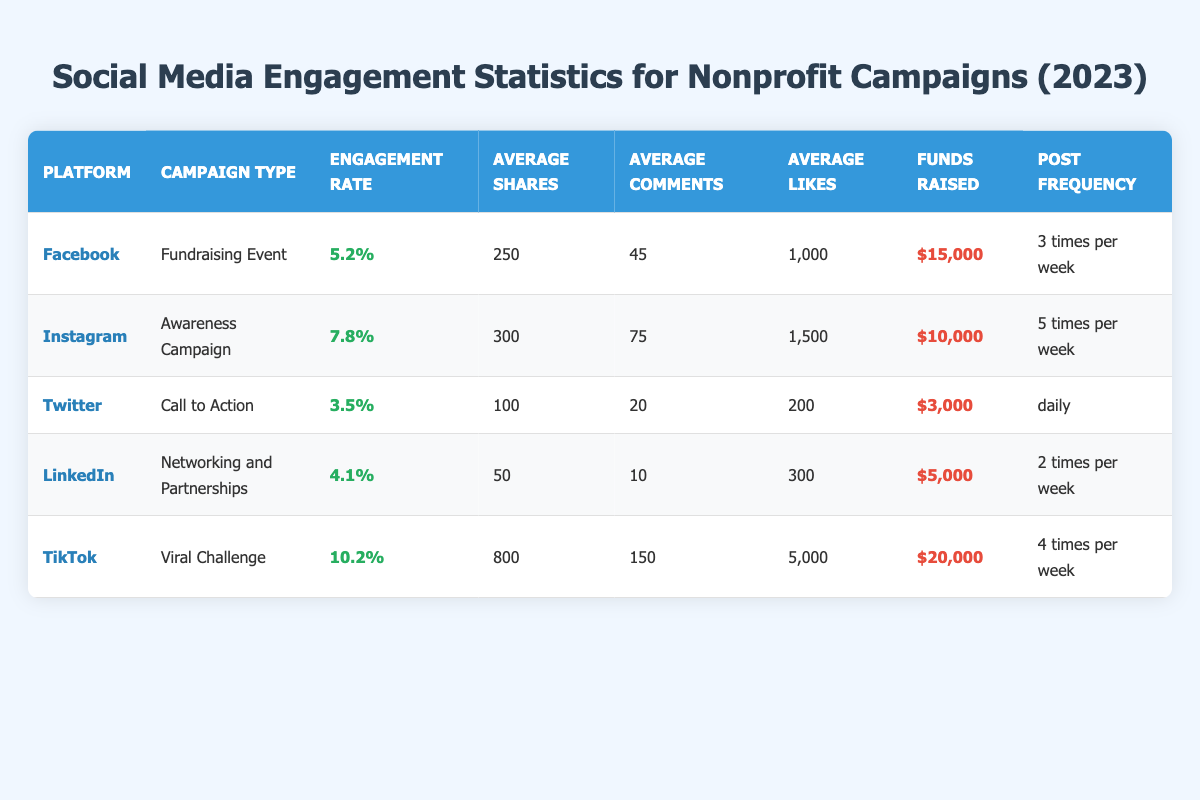What is the engagement rate for TikTok campaigns? The table shows that the engagement rate for TikTok campaigns is listed under the "Engagement Rate" column for TikTok, which is 10.2%.
Answer: 10.2% How many average likes did the Awareness Campaign on Instagram receive? Referring to the table, the average likes for the Awareness Campaign on Instagram are specifically noted as 1500 in the "Average Likes" column.
Answer: 1500 Which platform has the highest average shares and what is that number? By examining the "Average Shares" column for each platform, TikTok has the highest average shares at 800, as indicated in its respective row of the table.
Answer: 800 True or False: The fundraising event on Facebook raised more funds than the call to action on Twitter. The funds raised from Facebook's fundraising event are $15,000 and from Twitter's call to action are $3,000. Since $15,000 is greater than $3,000, the statement is true.
Answer: True What is the total amount of funds raised from the campaigns on Instagram and TikTok combined? The funds raised from Instagram are $10,000 and from TikTok are $20,000. Adding these together gives a total of $10,000 + $20,000 = $30,000.
Answer: $30,000 Which campaign type saw the least engagement rate and what was that rate? By comparing the engagement rates from the "Engagement Rate" column, Twitter's Call to Action has the least engagement rate at 3.5%, which is lower than the rates from all other campaigns.
Answer: 3.5% On average, how many times per week were posts made for all platforms listed? The post frequencies from each platform need to be converted into numbers: Facebook (3), Instagram (5), Twitter (7), LinkedIn (2), and TikTok (4). Adding these gives a total of 21, and dividing by 5 platforms yields an average of 21/5 = 4.2 times per week.
Answer: 4.2 times Which platform had the highest funds raised, and how does it compare with the lowest funds raised? The highest funds raised were on TikTok at $20,000, while the lowest funds raised were on Twitter at $3,000. Comparing these shows that TikTok raised $20,000 - $3,000 = $17,000 more than Twitter.
Answer: TikTok; $17,000 more How are the engagement rates distributed among the platforms? The engagement rates for each platform are: Facebook 5.2%, Instagram 7.8%, Twitter 3.5%, LinkedIn 4.1%, and TikTok 10.2%. Analyzing these rates shows that TikTok has the highest rate and Twitter has the lowest, indicating a range from 3.5% to 10.2%.
Answer: Ranges from 3.5% to 10.2% 